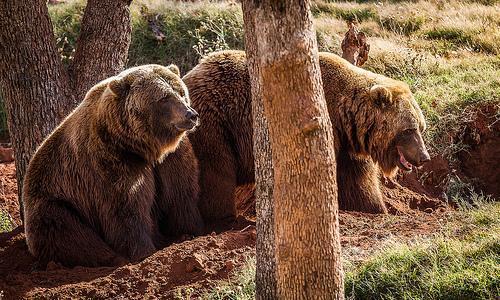How many bears are in the photo?
Give a very brief answer. 2. How many bears are there?
Give a very brief answer. 2. How many bears have a mouth open?
Give a very brief answer. 1. 